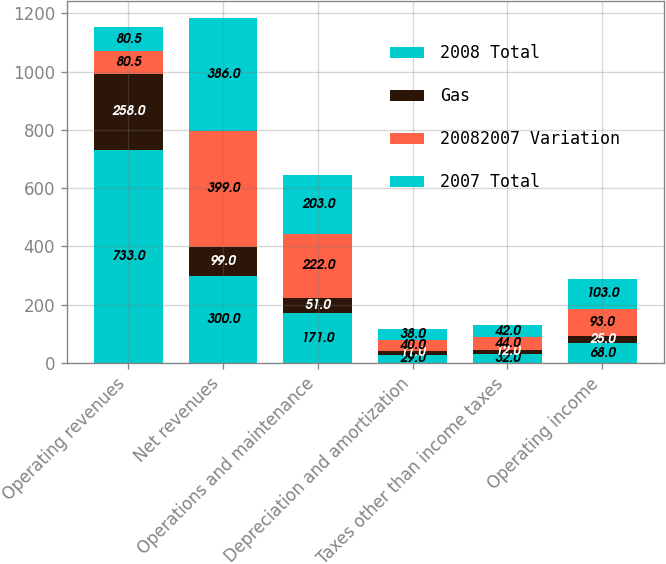<chart> <loc_0><loc_0><loc_500><loc_500><stacked_bar_chart><ecel><fcel>Operating revenues<fcel>Net revenues<fcel>Operations and maintenance<fcel>Depreciation and amortization<fcel>Taxes other than income taxes<fcel>Operating income<nl><fcel>2008 Total<fcel>733<fcel>300<fcel>171<fcel>29<fcel>32<fcel>68<nl><fcel>Gas<fcel>258<fcel>99<fcel>51<fcel>11<fcel>12<fcel>25<nl><fcel>20082007 Variation<fcel>80.5<fcel>399<fcel>222<fcel>40<fcel>44<fcel>93<nl><fcel>2007 Total<fcel>80.5<fcel>386<fcel>203<fcel>38<fcel>42<fcel>103<nl></chart> 